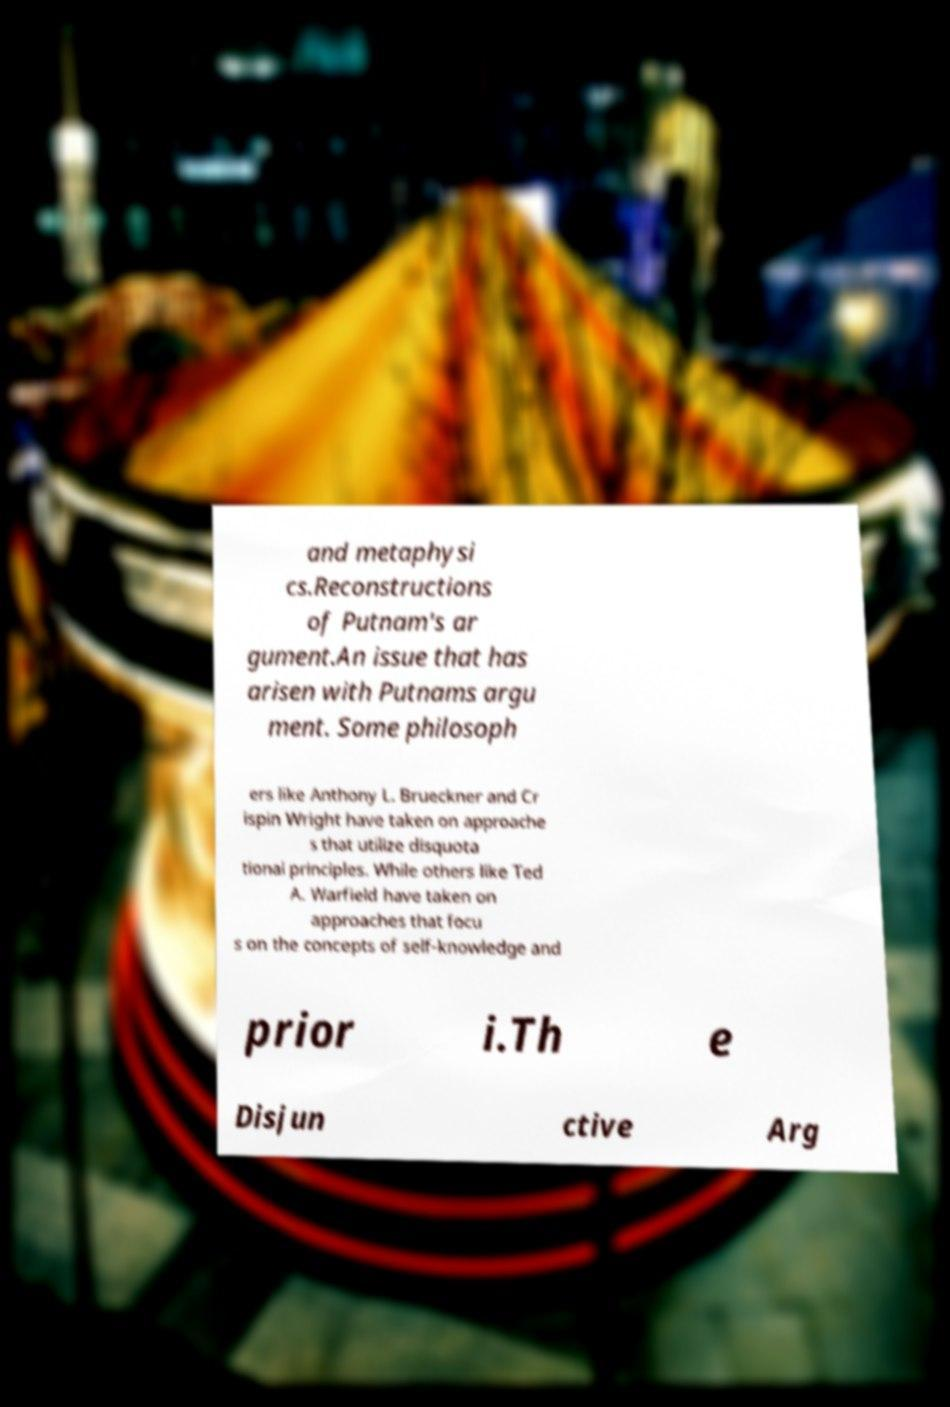Could you extract and type out the text from this image? and metaphysi cs.Reconstructions of Putnam's ar gument.An issue that has arisen with Putnams argu ment. Some philosoph ers like Anthony L. Brueckner and Cr ispin Wright have taken on approache s that utilize disquota tional principles. While others like Ted A. Warfield have taken on approaches that focu s on the concepts of self-knowledge and prior i.Th e Disjun ctive Arg 